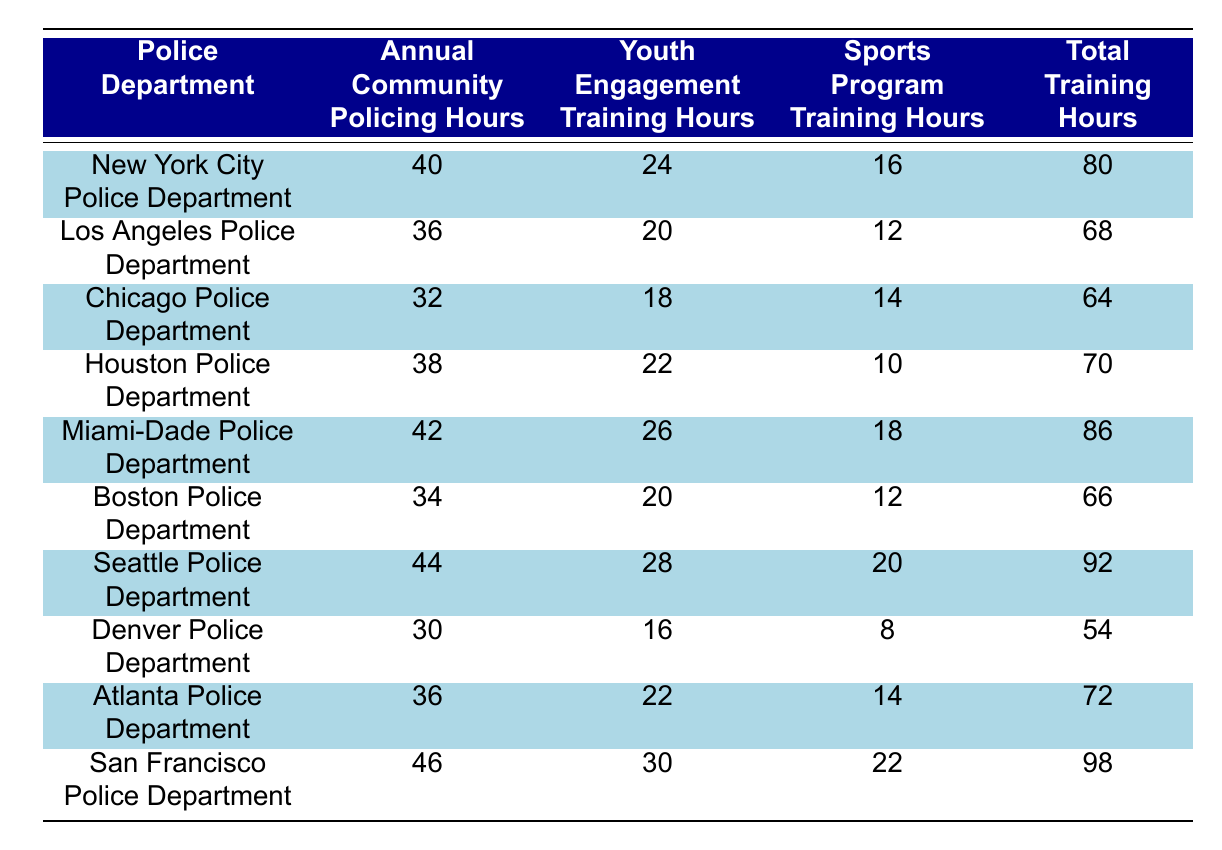What is the total training hours for San Francisco Police Department? According to the table, the row for the San Francisco Police Department lists the total training hours as 98.
Answer: 98 Which department has the highest youth engagement training hours? On examining the youth engagement training hours for each department, the San Francisco Police Department has the highest value of 30 hours.
Answer: San Francisco Police Department What are the total training hours for Miami-Dade Police Department? Referring to the Miami-Dade Police Department row, the total training hours are listed as 86.
Answer: 86 What is the average community policing hours across all departments? To calculate the average, sum the community policing hours (40 + 36 + 32 + 38 + 42 + 34 + 44 + 30 + 36 + 46 = 408) and divide by the number of departments (10). Thus, 408 / 10 = 40.8.
Answer: 40.8 Does the Chicago Police Department have more sports program training hours than the Denver Police Department? The Chicago Police Department has 14 sports program training hours, while the Denver Police Department has 8 hours. Therefore, Chicago has more.
Answer: Yes Which department has the least total training hours? The total training hours for Denver Police Department is 54, which is lower than all other departments listed in the table.
Answer: Denver Police Department How many more community policing hours does Seattle Police Department have compared to Houston Police Department? The Seattle Police Department has 44 community policing hours, while Houston has 38. The difference is calculated as 44 - 38 = 6.
Answer: 6 Are there any departments that have equal annual community policing and youth engagement training hours? By checking the values, no department has equal annual community policing hours and youth engagement training hours; they all differ.
Answer: No What is the total of youth engagement training hours for the top three police departments with the highest hours? The top three departments by youth engagement hours are San Francisco (30), Seattle (28), and Miami-Dade (26). Their total is 30 + 28 + 26 = 84.
Answer: 84 